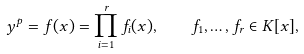<formula> <loc_0><loc_0><loc_500><loc_500>y ^ { p } = f ( x ) = \prod _ { i = 1 } ^ { r } f _ { i } ( x ) , \quad f _ { 1 } , \dots , f _ { r } \in K [ x ] ,</formula> 